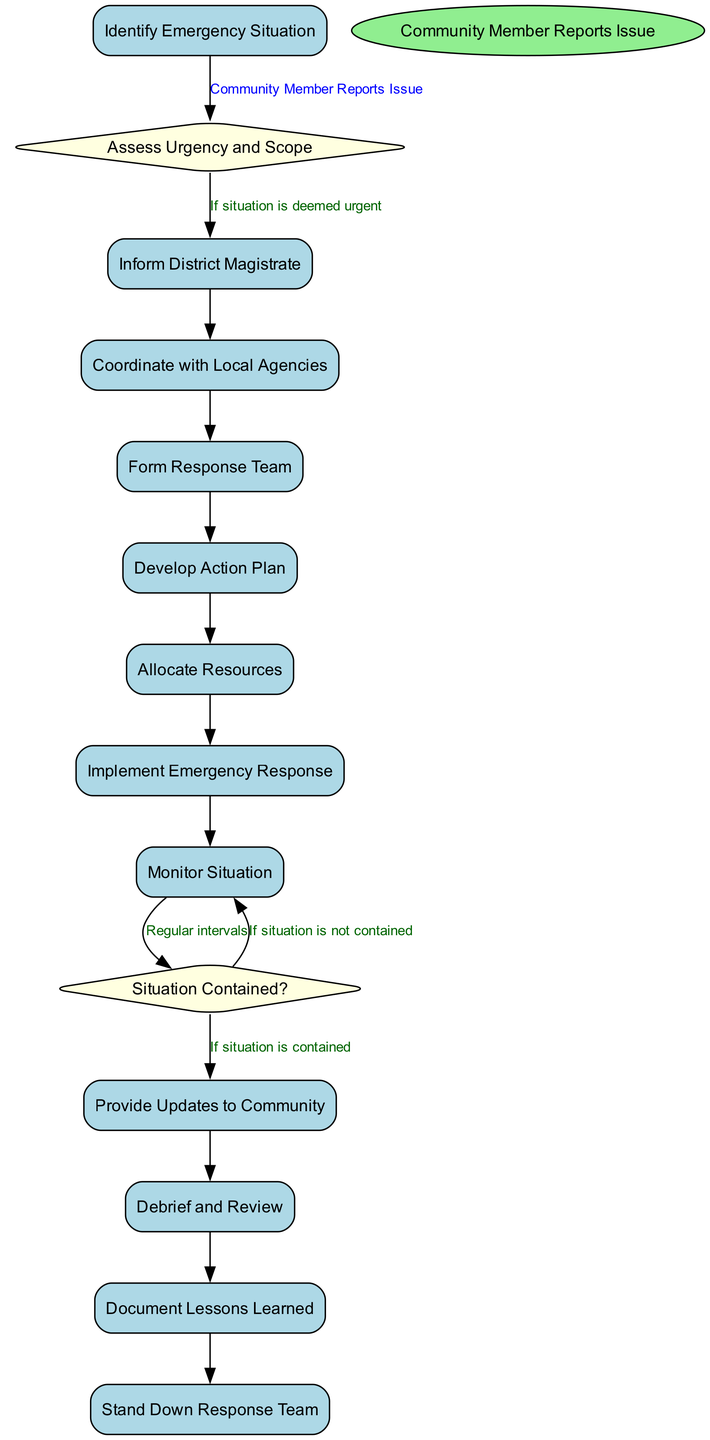What triggers the "Assess Urgency and Scope" activity? The trigger for the "Assess Urgency and Scope" activity is the "Community Member Reports Issue" event, indicating that a community member has brought an issue to attention that necessitates assessment.
Answer: Community Member Reports Issue How many activities are present in the diagram? The total number of activities in the diagram includes: "Identify Emergency Situation", "Inform District Magistrate", "Coordinate with Local Agencies", "Form Response Team", "Develop Action Plan", "Allocate Resources", "Implement Emergency Response", "Monitor Situation", "Provide Updates to Community", "Debrief and Review", "Document Lessons Learned", and "Stand Down Response Team". This totals to 11 activities.
Answer: 11 What happens if the situation is not contained during monitoring? If the situation is not contained during monitoring, the flow transitions back to "Monitor Situation" for ongoing observation and intervention as necessary, indicating that further actions are required to regain control.
Answer: Monitor Situation Which activity follows "Develop Action Plan"? Following "Develop Action Plan", the next activity in the flow is "Allocate Resources", indicating that once a plan is developed, resources need to be allocated accordingly for implementation.
Answer: Allocate Resources Which decision is made after monitoring the situation? After monitoring the situation, a decision is made to determine if the "Situation Contained?", which directs the next steps based on whether the emergency has been successfully managed.
Answer: Situation Contained? 